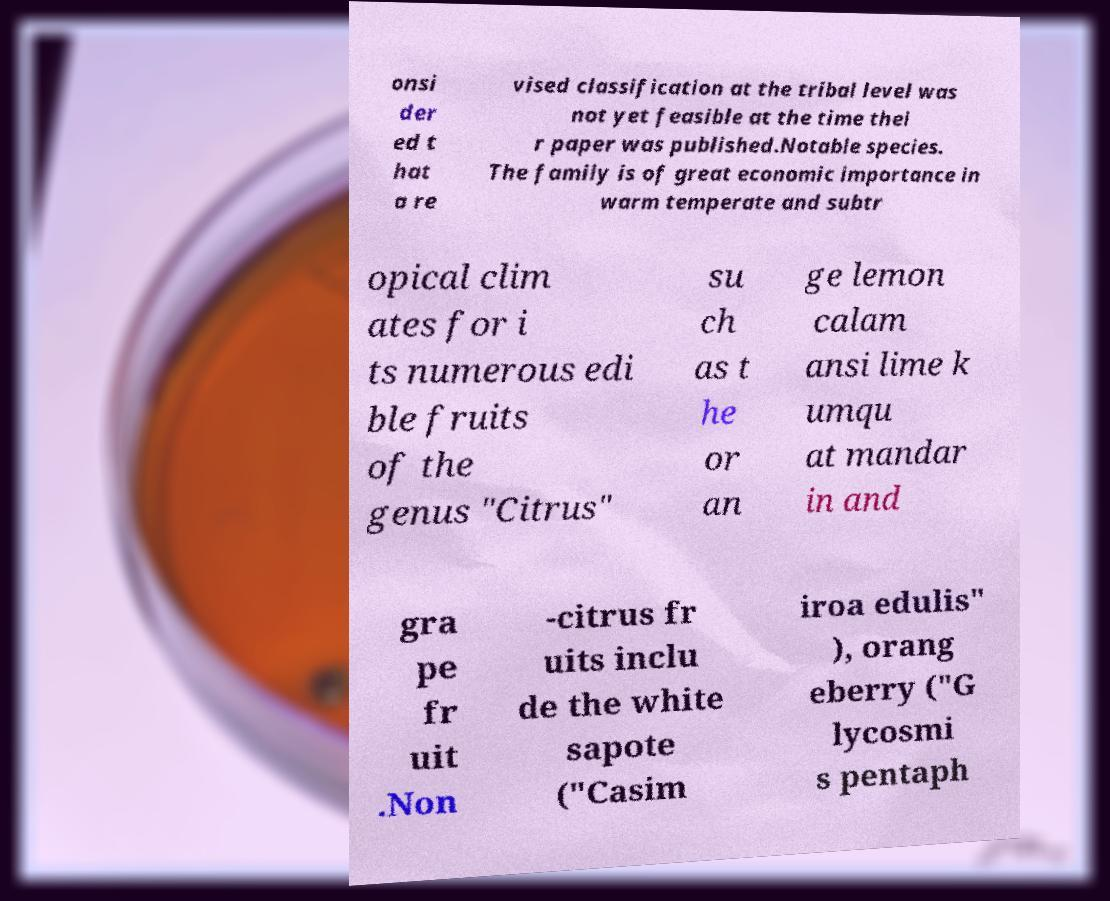Could you extract and type out the text from this image? onsi der ed t hat a re vised classification at the tribal level was not yet feasible at the time thei r paper was published.Notable species. The family is of great economic importance in warm temperate and subtr opical clim ates for i ts numerous edi ble fruits of the genus "Citrus" su ch as t he or an ge lemon calam ansi lime k umqu at mandar in and gra pe fr uit .Non -citrus fr uits inclu de the white sapote ("Casim iroa edulis" ), orang eberry ("G lycosmi s pentaph 